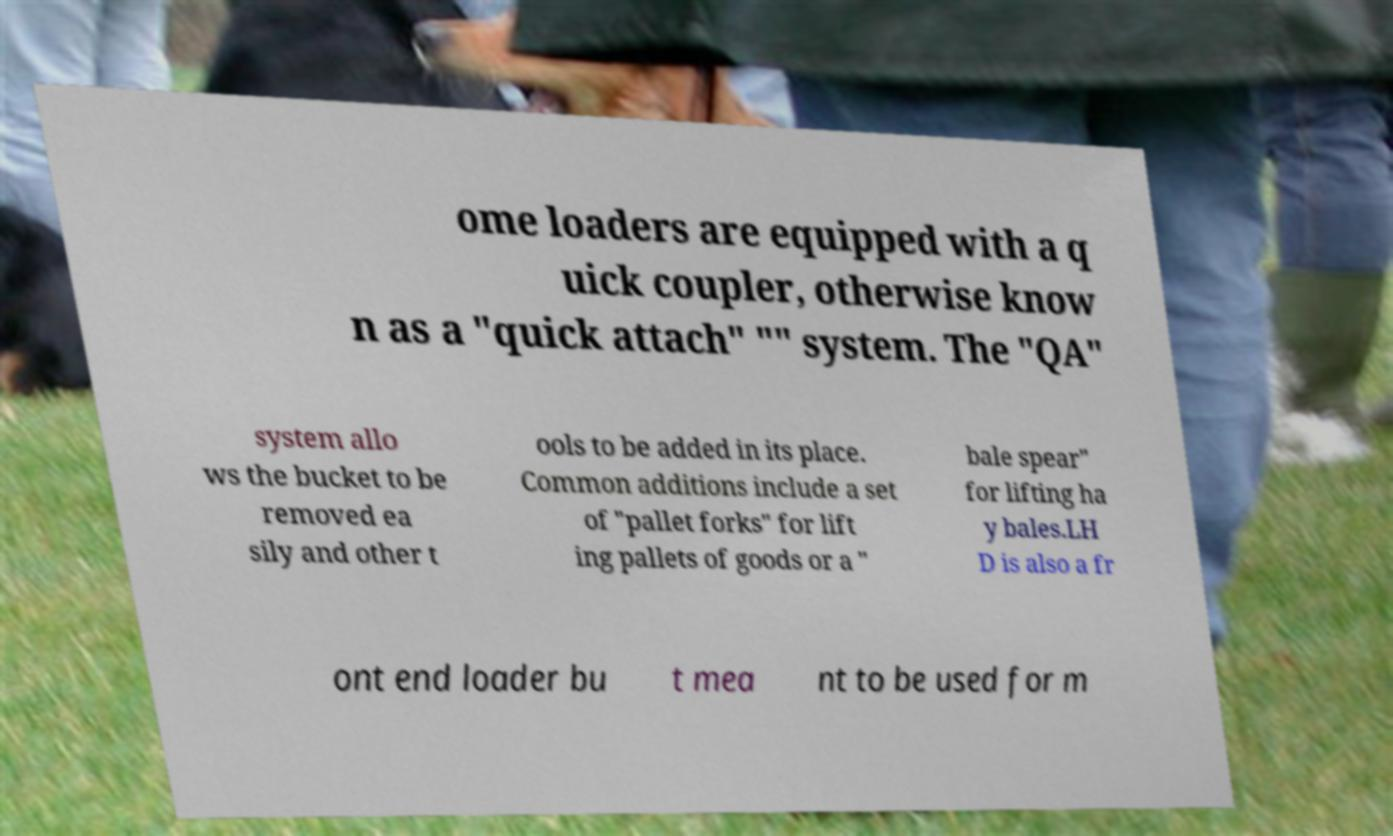Could you assist in decoding the text presented in this image and type it out clearly? ome loaders are equipped with a q uick coupler, otherwise know n as a "quick attach" "" system. The "QA" system allo ws the bucket to be removed ea sily and other t ools to be added in its place. Common additions include a set of "pallet forks" for lift ing pallets of goods or a " bale spear" for lifting ha y bales.LH D is also a fr ont end loader bu t mea nt to be used for m 